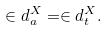<formula> <loc_0><loc_0><loc_500><loc_500>\in d _ { a } ^ { X } = \in d _ { t } ^ { X } .</formula> 